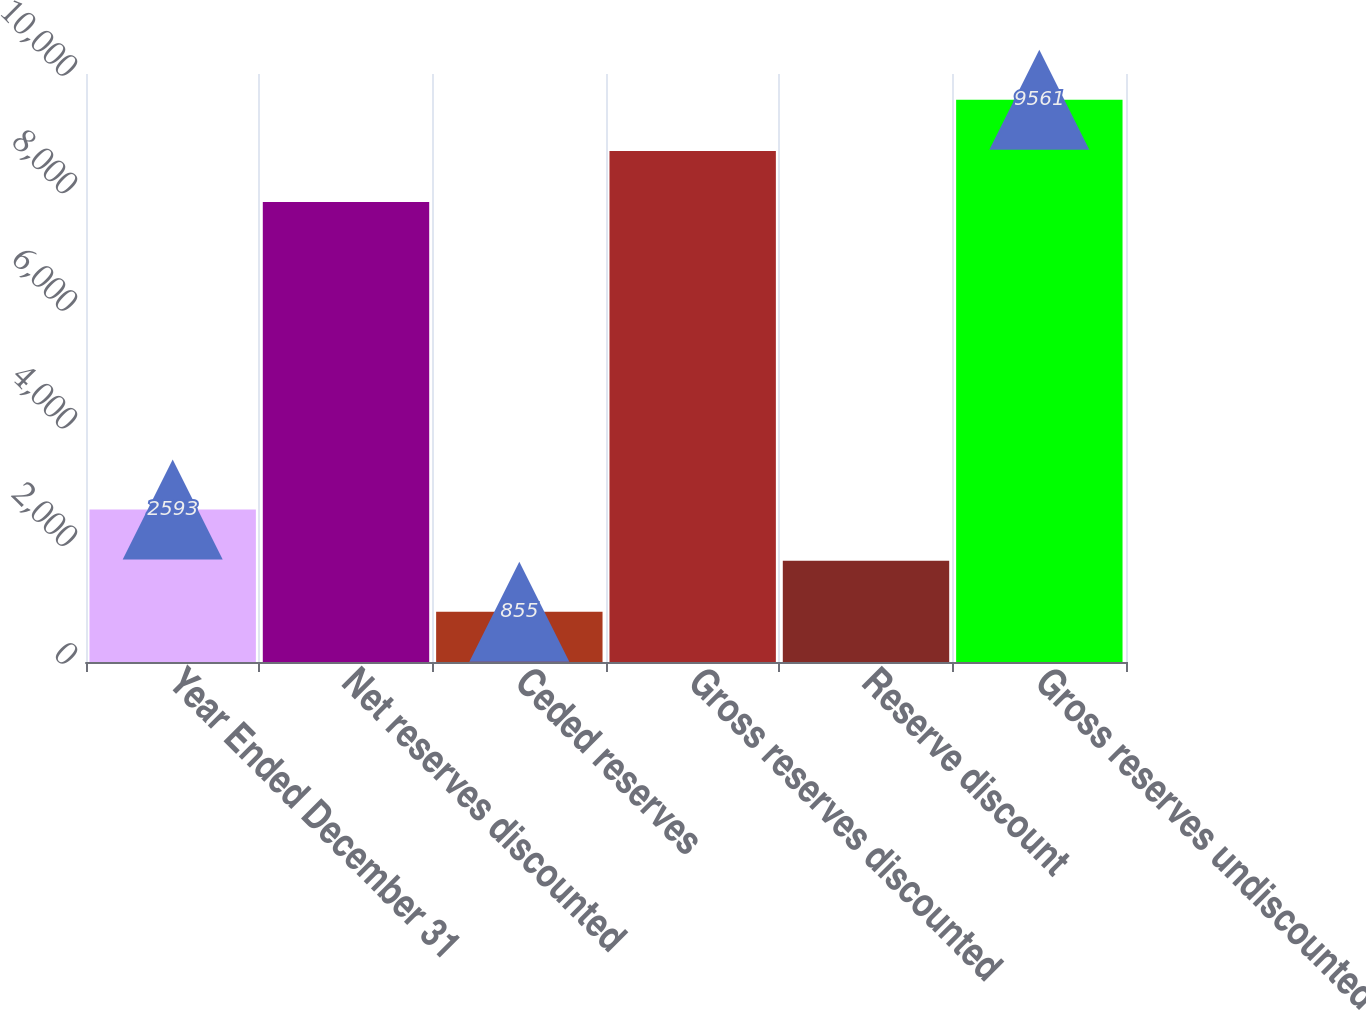Convert chart. <chart><loc_0><loc_0><loc_500><loc_500><bar_chart><fcel>Year Ended December 31<fcel>Net reserves discounted<fcel>Ceded reserves<fcel>Gross reserves discounted<fcel>Reserve discount<fcel>Gross reserves undiscounted<nl><fcel>2593<fcel>7823<fcel>855<fcel>8692<fcel>1724<fcel>9561<nl></chart> 